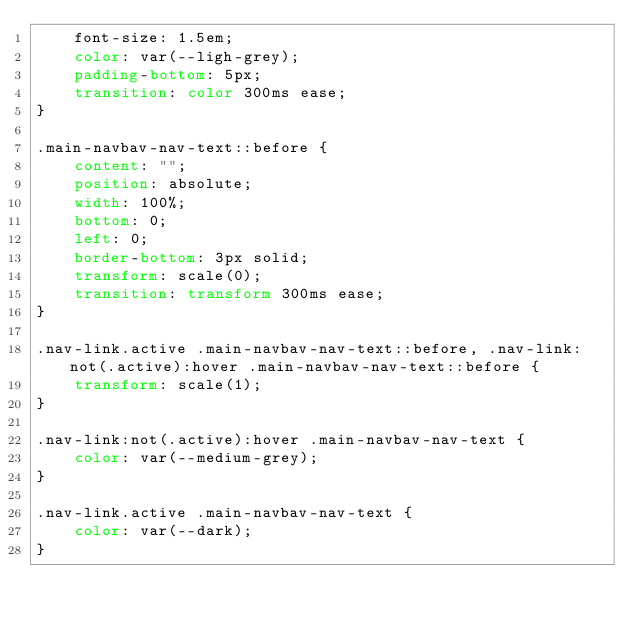Convert code to text. <code><loc_0><loc_0><loc_500><loc_500><_CSS_>    font-size: 1.5em;
    color: var(--ligh-grey);
    padding-bottom: 5px;
    transition: color 300ms ease;
}

.main-navbav-nav-text::before {
    content: "";
    position: absolute;
    width: 100%;
    bottom: 0;
    left: 0;
    border-bottom: 3px solid;
    transform: scale(0);
    transition: transform 300ms ease;
}

.nav-link.active .main-navbav-nav-text::before, .nav-link:not(.active):hover .main-navbav-nav-text::before {
    transform: scale(1);
}

.nav-link:not(.active):hover .main-navbav-nav-text {
    color: var(--medium-grey);
}

.nav-link.active .main-navbav-nav-text {
    color: var(--dark);
}

</code> 